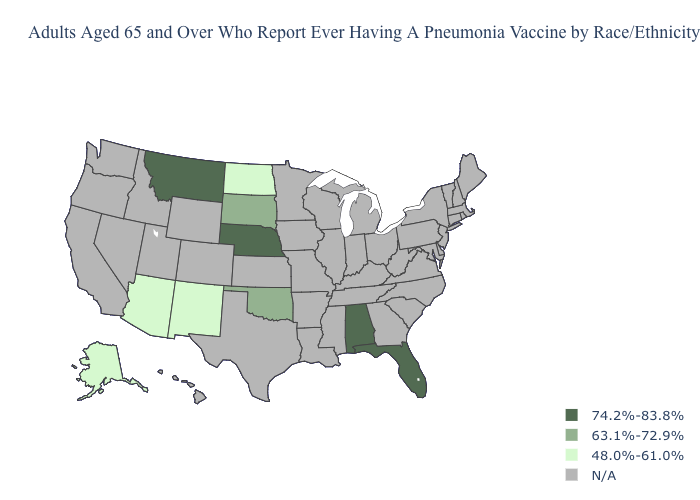Name the states that have a value in the range 74.2%-83.8%?
Give a very brief answer. Alabama, Florida, Montana, Nebraska. Name the states that have a value in the range 63.1%-72.9%?
Answer briefly. Oklahoma, South Dakota. Name the states that have a value in the range N/A?
Be succinct. Arkansas, California, Colorado, Connecticut, Delaware, Georgia, Hawaii, Idaho, Illinois, Indiana, Iowa, Kansas, Kentucky, Louisiana, Maine, Maryland, Massachusetts, Michigan, Minnesota, Mississippi, Missouri, Nevada, New Hampshire, New Jersey, New York, North Carolina, Ohio, Oregon, Pennsylvania, Rhode Island, South Carolina, Tennessee, Texas, Utah, Vermont, Virginia, Washington, West Virginia, Wisconsin, Wyoming. Name the states that have a value in the range 63.1%-72.9%?
Quick response, please. Oklahoma, South Dakota. What is the value of Arizona?
Be succinct. 48.0%-61.0%. Among the states that border Nevada , which have the lowest value?
Give a very brief answer. Arizona. What is the value of Arizona?
Short answer required. 48.0%-61.0%. Name the states that have a value in the range 63.1%-72.9%?
Quick response, please. Oklahoma, South Dakota. Name the states that have a value in the range 48.0%-61.0%?
Concise answer only. Alaska, Arizona, New Mexico, North Dakota. Which states hav the highest value in the MidWest?
Give a very brief answer. Nebraska. What is the value of Massachusetts?
Answer briefly. N/A. Which states hav the highest value in the West?
Quick response, please. Montana. Does Montana have the lowest value in the USA?
Quick response, please. No. Name the states that have a value in the range N/A?
Short answer required. Arkansas, California, Colorado, Connecticut, Delaware, Georgia, Hawaii, Idaho, Illinois, Indiana, Iowa, Kansas, Kentucky, Louisiana, Maine, Maryland, Massachusetts, Michigan, Minnesota, Mississippi, Missouri, Nevada, New Hampshire, New Jersey, New York, North Carolina, Ohio, Oregon, Pennsylvania, Rhode Island, South Carolina, Tennessee, Texas, Utah, Vermont, Virginia, Washington, West Virginia, Wisconsin, Wyoming. 